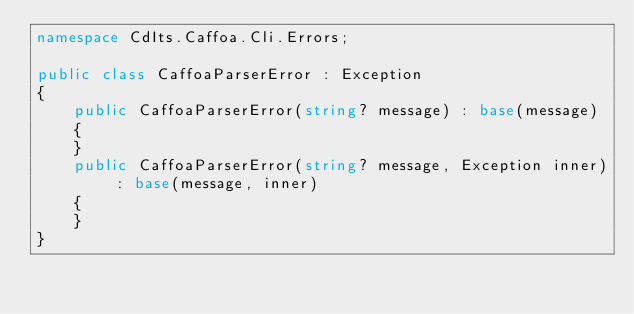Convert code to text. <code><loc_0><loc_0><loc_500><loc_500><_C#_>namespace CdIts.Caffoa.Cli.Errors;

public class CaffoaParserError : Exception
{
    public CaffoaParserError(string? message) : base(message)
    {
    }
    public CaffoaParserError(string? message, Exception inner) : base(message, inner)
    {
    }
}
</code> 